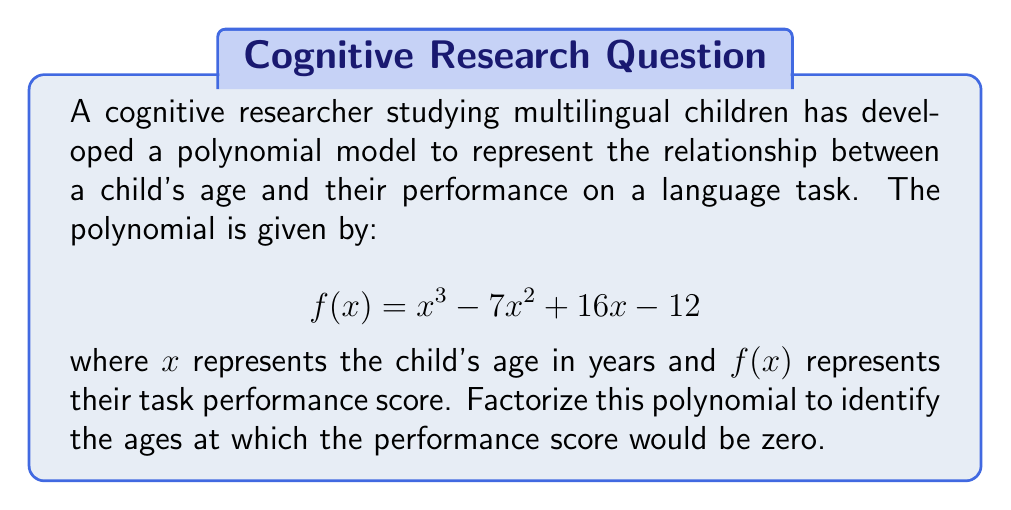Provide a solution to this math problem. To factorize this polynomial, we'll follow these steps:

1) First, let's check if there's a common factor. In this case, there isn't.

2) Next, we'll try to guess one factor. Since the constant term is -12, potential factors could be ±1, ±2, ±3, ±4, ±6, or ±12. Let's try these:

   $f(1) = 1 - 7 + 16 - 12 = -2$ (not a factor)
   $f(2) = 8 - 28 + 32 - 12 = 0$ (this is a factor)

3) So, $(x - 2)$ is a factor. We can divide the original polynomial by $(x - 2)$ to find the other factor:

   $$\frac{x^3 - 7x^2 + 16x - 12}{x - 2} = x^2 - 5x + 6$$

4) Now we need to factorize $x^2 - 5x + 6$. We're looking for two numbers that multiply to give 6 and add to give -5. These numbers are -2 and -3.

5) Therefore, $x^2 - 5x + 6 = (x - 2)(x - 3)$

6) Combining all factors, we get:

   $$f(x) = (x - 2)(x - 2)(x - 3)$$

   or

   $$f(x) = (x - 2)^2(x - 3)$$

This factorization shows that the performance score would be zero when $x = 2$ or $x = 3$.
Answer: $(x - 2)^2(x - 3)$ 